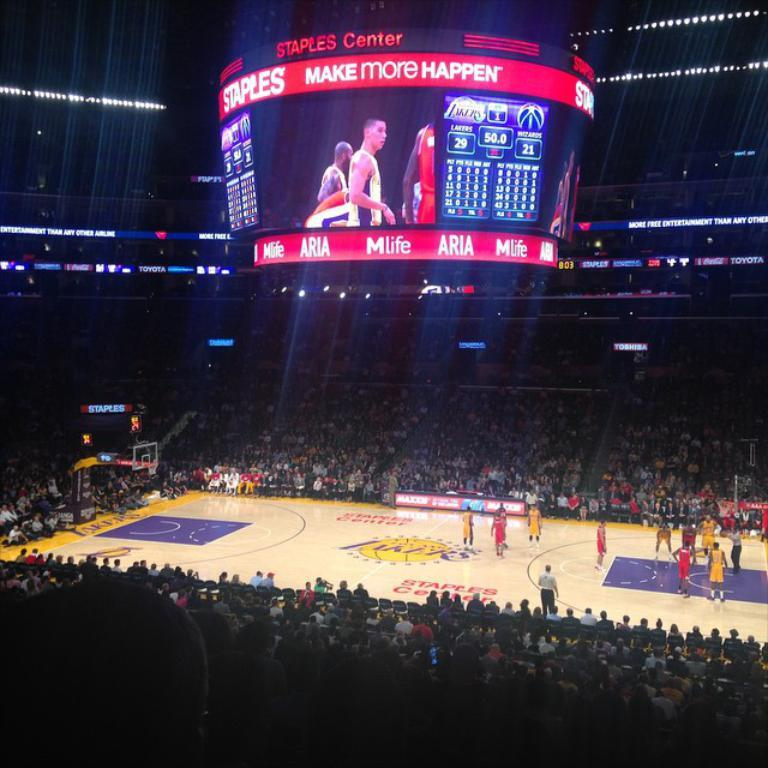<image>
Offer a succinct explanation of the picture presented. An indoor basketball arena with, Make more Happen, on the overhead scoreboard. 